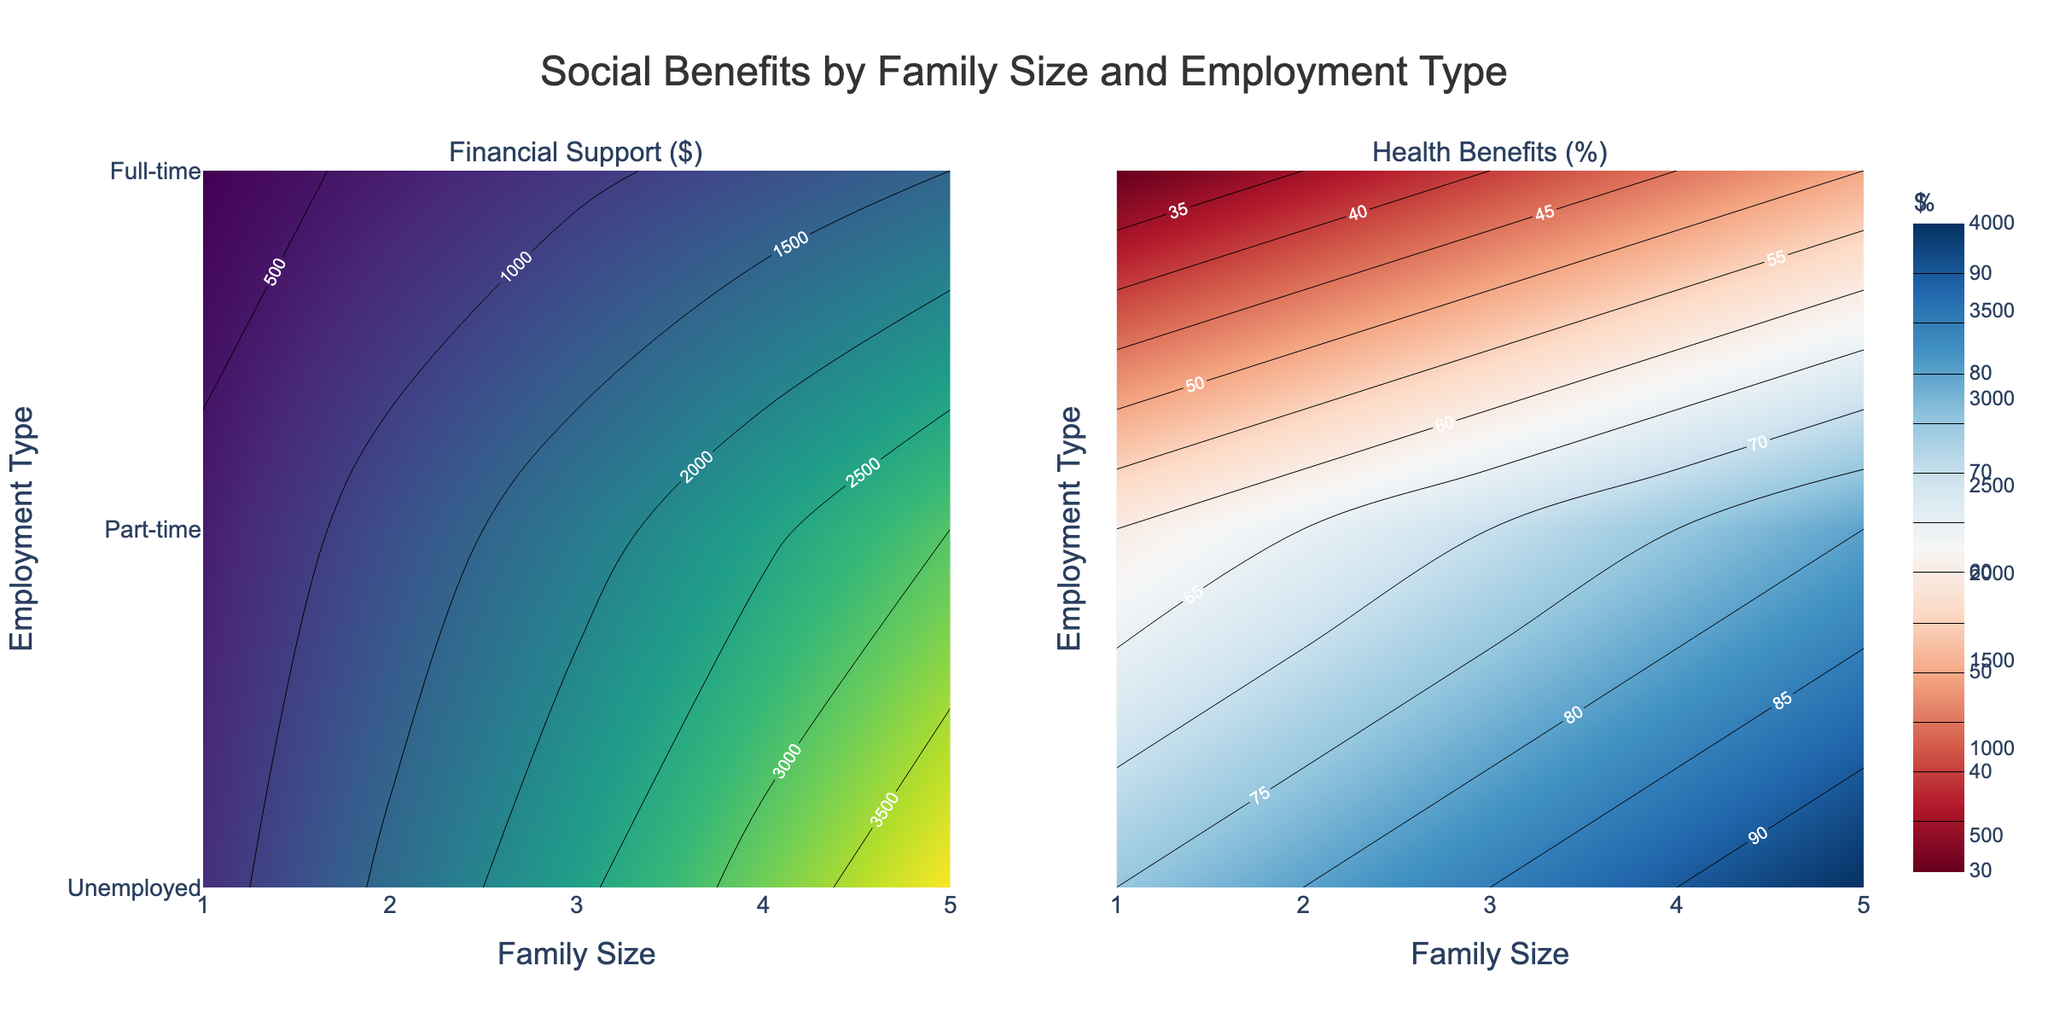How does financial support vary by family size and employment type? The contour plot for financial support ($) shows that financial support increases with family size. Among employment types, unemployed families receive the highest financial support, followed by part-time, and full-time receives the least support.
Answer: Financial support increases with family size and is highest for unemployed families What is the title of the plots? The title is located at the top center of the figure and it clearly mentions the scope of the data.
Answer: Social Benefits by Family Size and Employment Type Which employment type has the highest health benefits across all family sizes? In the contour plot for health benefits (%), the unemployed category consistently shows the highest percentage across all family sizes.
Answer: Unemployed For a family size of 3, which employment type receives the lowest financial support? By looking at the contour plot for financial support ($) at the x-axis value of 3, 'Full-time' has the lowest shaded contour indicating the least amount received.
Answer: Full-time How do health benefits change for full-time employed individuals as the family size increases? Observing the contour plot for health benefits (%), the percentage gradually increases from 30% for family size 1 to 50% for family size 5 for full-time employees.
Answer: They increase from 30% to 50% Compare the financial support for a family size of 4 across different employment types. By referring to the contour plot for financial support, families of size 4 receive $3200 if unemployed, $2400 if part-time, and $1200 if full-time. The sum is 3200+2400+1200=6800 and the average is 6800/3 ≈ 2267.
Answer: $3200 (unemployed), $2400 (part-time), $1200 (full-time) Which family size receives the highest health benefits, and what is the amount? On the contour plot for health benefits, the highest value is seen at a family size of 5 for the unemployed, which is 95%.
Answer: Family size 5, 95% Between part-time and full-time employments, which has a more significant increase in financial support from a family size of 1 to 5? Comparing the difference in contour values between family sizes 1 and 5, part-time rises from $600 to $3000 (a $2400 increase) while full-time rises from $300 to $1500 (a $1200 increase).
Answer: Part-time What trend do you observe for financial support as the family size increases for unemployed individuals? In the contour plot for financial support, the values increase linearly from $800 for a family size of 1 to $4000 for a family size of 5, indicating a steady rise.
Answer: It increases linearly Which has a steeper gradient change in health benefits: going from family size 1 to 5 for unemployed or part-time? Observing the contour plot for health benefits, the increase is from 75% to 95% (20%) for unemployed and from 60% to 80% (20%) for part-time, so the change is equal in terms of percentage increase.
Answer: Both have equal gradients 